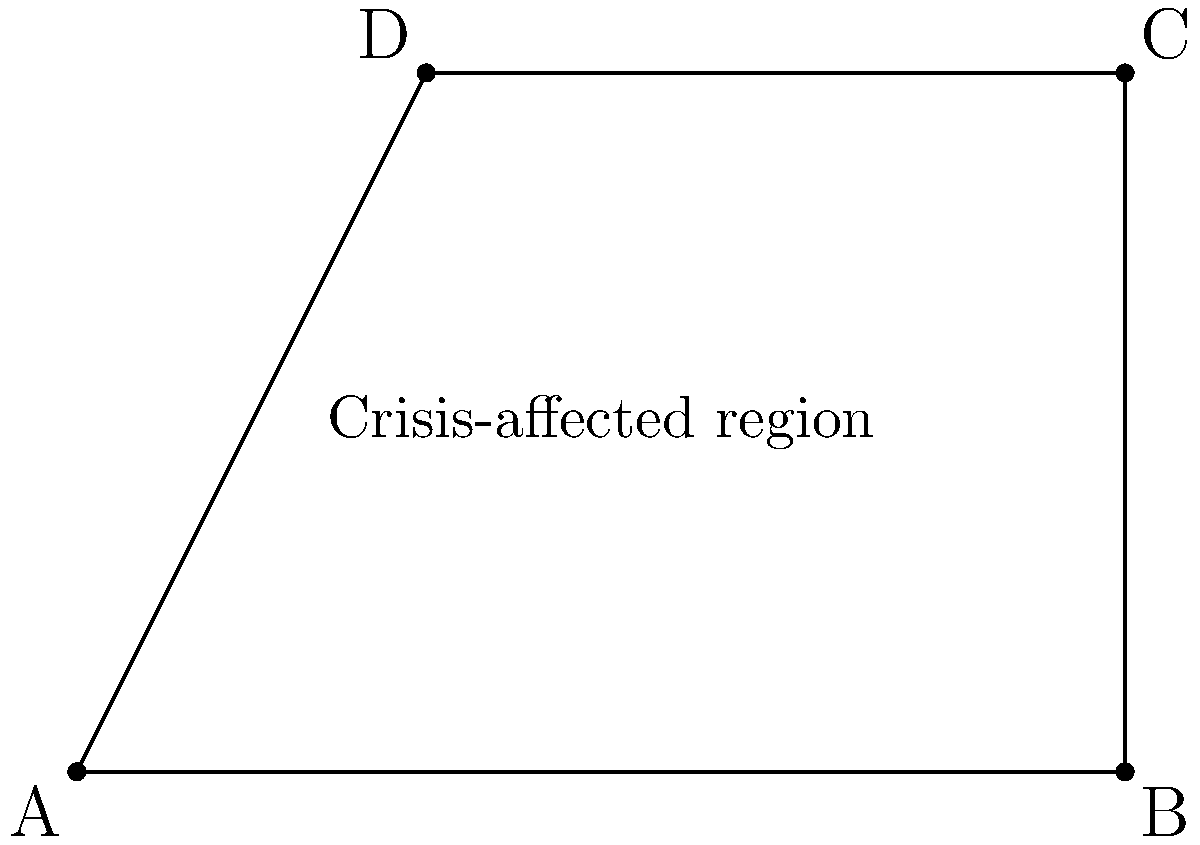As a mental health coordinator for journalists in conflict zones, you need to estimate the area affected by a crisis. The region is represented by a quadrilateral ABCD on a coordinate plane. Given the coordinates A(0,0), B(6,0), C(6,4), and D(2,4), calculate the area of the affected region in square units. To calculate the area of the quadrilateral ABCD, we can divide it into two triangles and sum their areas. Let's follow these steps:

1. Divide the quadrilateral into triangles ABC and ACD.

2. Calculate the area of triangle ABC:
   Base = AB = 6 units
   Height = BC = 4 units
   Area of ABC = $\frac{1}{2} \times base \times height = \frac{1}{2} \times 6 \times 4 = 12$ square units

3. Calculate the area of triangle ACD:
   We can use the formula: $Area = \frac{1}{2}|x_1(y_2 - y_3) + x_2(y_3 - y_1) + x_3(y_1 - y_2)|$
   Where $(x_1, y_1)$, $(x_2, y_2)$, and $(x_3, y_3)$ are the coordinates of the three points.

   $Area_{ACD} = \frac{1}{2}|0(4 - 4) + 6(4 - 0) + 2(0 - 4)|$
                $= \frac{1}{2}|0 + 24 - 8|$
                $= \frac{1}{2} \times 16 = 8$ square units

4. Sum the areas of the two triangles:
   Total Area = Area of ABC + Area of ACD
               $= 12 + 8 = 20$ square units

Therefore, the total area of the crisis-affected region is 20 square units.
Answer: 20 square units 